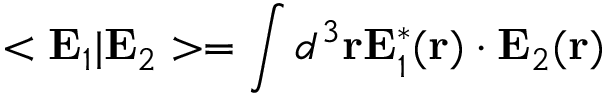<formula> <loc_0><loc_0><loc_500><loc_500>< { E } _ { 1 } | { E } _ { 2 } > = \int d ^ { 3 } { r } { E } _ { 1 } ^ { * } ( { r } ) \cdot { E } _ { 2 } ( { r } )</formula> 